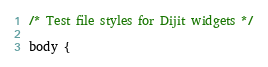Convert code to text. <code><loc_0><loc_0><loc_500><loc_500><_CSS_>/* Test file styles for Dijit widgets */

body {</code> 